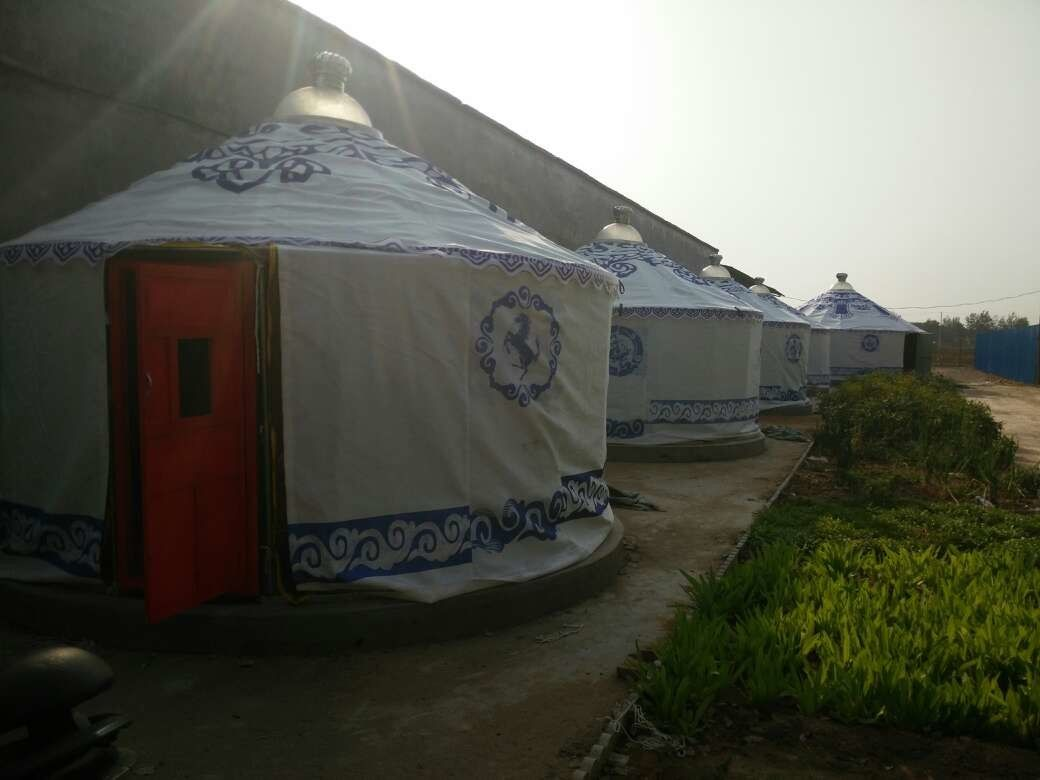Considering the environment and structures, for what kind of event or purpose could this site be prepared? The image showcases a series of yurts, which are traditional portable tents often used by nomadic cultures in Central Asia. These yurts are set up in a cultivated area, suggesting that the site is prepared for an event requiring temporary but comfortable accommodation. The presence of a portable toilet cabin indicates that the event is expected to host a considerable number of attendees over several days. This setup is ideal for festivals, cultural exhibitions, educational camps, or even ecological retreats. The decorative patterns on the yurts hint at a celebration or event focusing on cultural heritage, possibly aimed at educating visitors about the traditions and lifestyles of Central Asian nomadic communities. The aesthetic planning of green areas further indicates an effort to create a pleasant environment for visitors. 